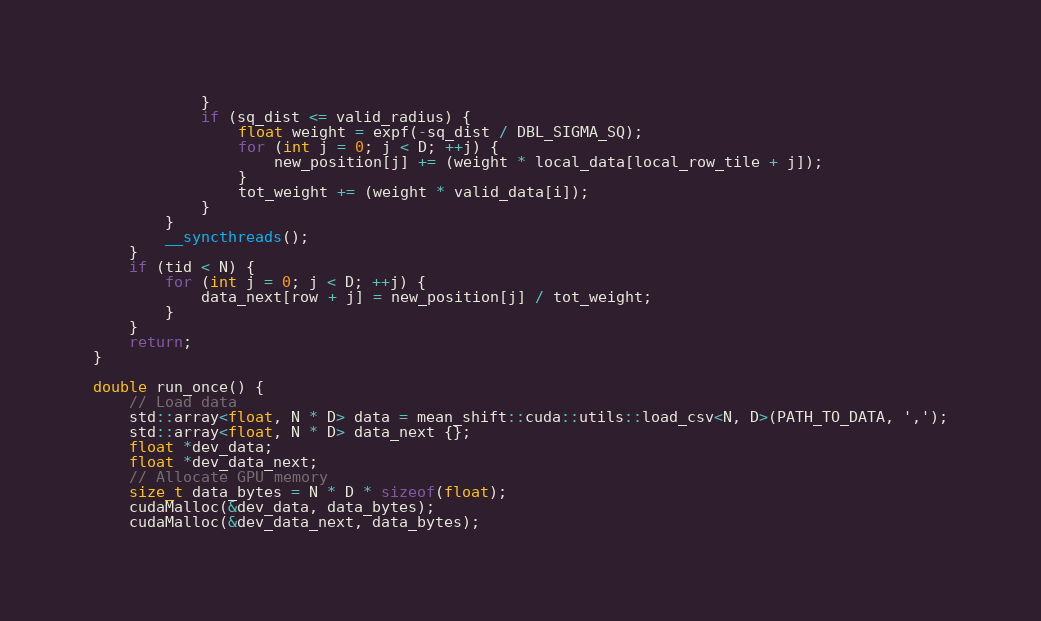Convert code to text. <code><loc_0><loc_0><loc_500><loc_500><_Cuda_>            }
            if (sq_dist <= valid_radius) {
                float weight = expf(-sq_dist / DBL_SIGMA_SQ);
                for (int j = 0; j < D; ++j) {
                    new_position[j] += (weight * local_data[local_row_tile + j]);
                }
                tot_weight += (weight * valid_data[i]);
            }
        }
        __syncthreads();
    }
    if (tid < N) {
        for (int j = 0; j < D; ++j) {
            data_next[row + j] = new_position[j] / tot_weight;
        }
    }
    return;
}

double run_once() {
    // Load data
    std::array<float, N * D> data = mean_shift::cuda::utils::load_csv<N, D>(PATH_TO_DATA, ',');
    std::array<float, N * D> data_next {};
    float *dev_data;
    float *dev_data_next;
    // Allocate GPU memory
    size_t data_bytes = N * D * sizeof(float);
    cudaMalloc(&dev_data, data_bytes);
    cudaMalloc(&dev_data_next, data_bytes);</code> 